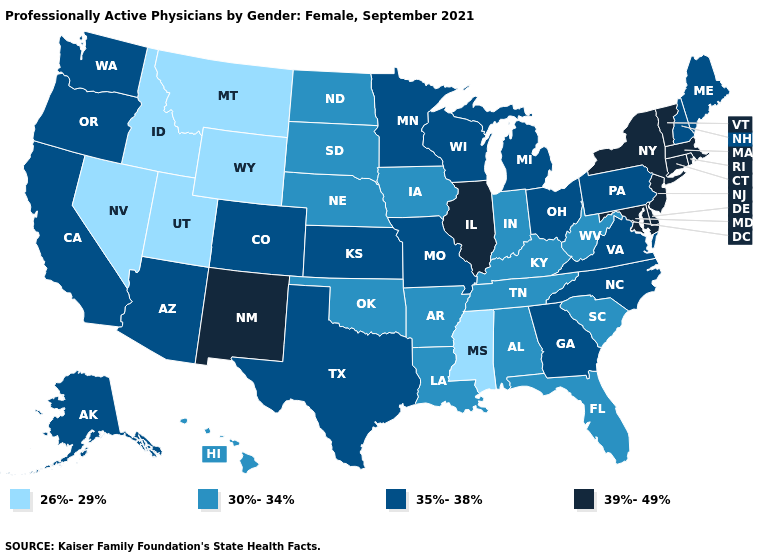What is the value of North Dakota?
Answer briefly. 30%-34%. Name the states that have a value in the range 26%-29%?
Short answer required. Idaho, Mississippi, Montana, Nevada, Utah, Wyoming. Does Indiana have a higher value than Arkansas?
Be succinct. No. Does New Mexico have the highest value in the West?
Give a very brief answer. Yes. What is the value of Maine?
Write a very short answer. 35%-38%. Name the states that have a value in the range 26%-29%?
Quick response, please. Idaho, Mississippi, Montana, Nevada, Utah, Wyoming. What is the highest value in the USA?
Be succinct. 39%-49%. Does Nevada have the highest value in the USA?
Give a very brief answer. No. Name the states that have a value in the range 35%-38%?
Be succinct. Alaska, Arizona, California, Colorado, Georgia, Kansas, Maine, Michigan, Minnesota, Missouri, New Hampshire, North Carolina, Ohio, Oregon, Pennsylvania, Texas, Virginia, Washington, Wisconsin. What is the lowest value in the Northeast?
Quick response, please. 35%-38%. What is the value of Nevada?
Concise answer only. 26%-29%. What is the value of New Mexico?
Write a very short answer. 39%-49%. Name the states that have a value in the range 35%-38%?
Short answer required. Alaska, Arizona, California, Colorado, Georgia, Kansas, Maine, Michigan, Minnesota, Missouri, New Hampshire, North Carolina, Ohio, Oregon, Pennsylvania, Texas, Virginia, Washington, Wisconsin. Among the states that border New Jersey , which have the lowest value?
Be succinct. Pennsylvania. 